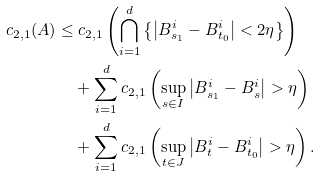<formula> <loc_0><loc_0><loc_500><loc_500>c _ { 2 , 1 } ( A ) \leq & \ c _ { 2 , 1 } \left ( \bigcap _ { i = 1 } ^ { d } \left \{ \left | B _ { s _ { 1 } } ^ { i } - B _ { t _ { 0 } } ^ { i } \right | < 2 \eta \right \} \right ) \\ & + \sum _ { i = 1 } ^ { d } c _ { 2 , 1 } \left ( \sup _ { s \in I } \left | B _ { s _ { 1 } } ^ { i } - B _ { s } ^ { i } \right | > \eta \right ) \\ & + \sum _ { i = 1 } ^ { d } c _ { 2 , 1 } \left ( \sup _ { t \in J } \left | B _ { t } ^ { i } - B _ { t _ { 0 } } ^ { i } \right | > \eta \right ) .</formula> 